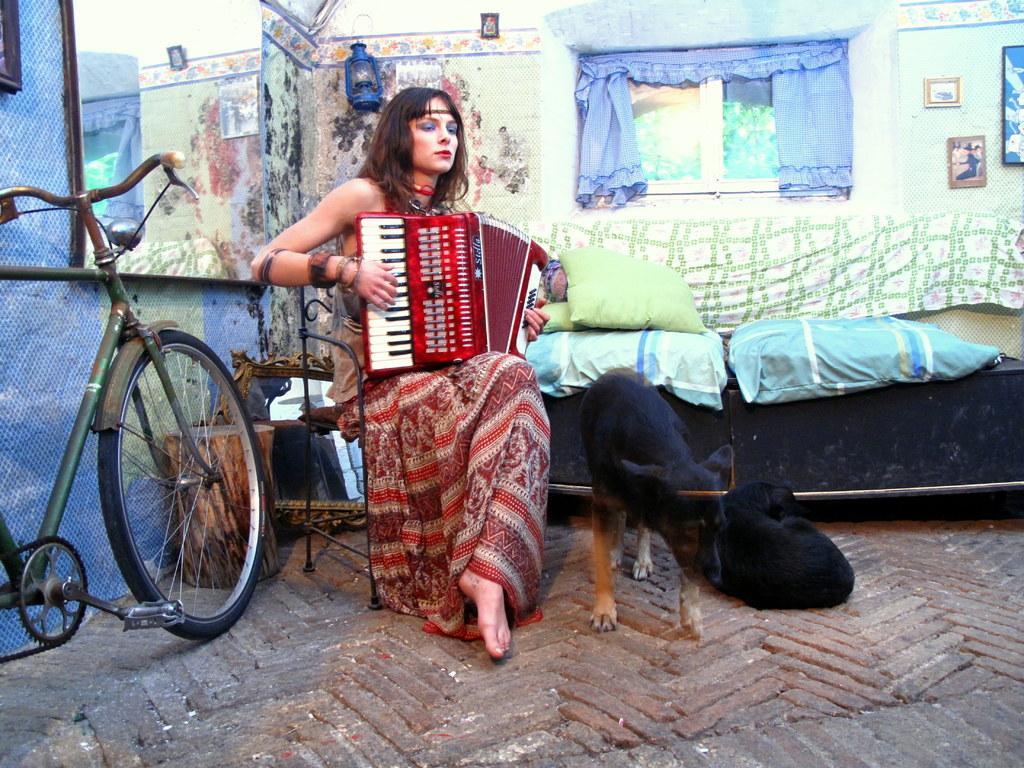Could you give a brief overview of what you see in this image? A person is sitting on a chair and playing a red color harmonium. There is a bicycle and a mirror on the wall at the left. At the right there are 2 black dogs. Behind her there are pillows, window, curtains, photo frames and a lantern is hanging on the wall. 